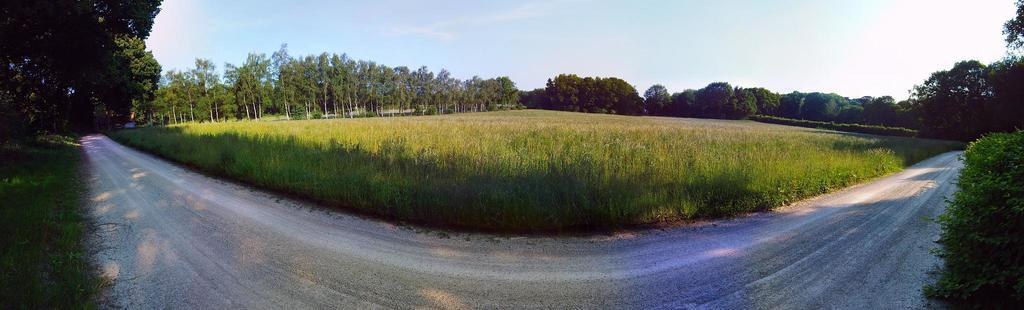What type of vegetation can be seen in the image? There are trees in the image. What type of surface is visible in the image? There is a road in the image. What type of ground cover is present in the image? There is grass in the image. What is visible in the background of the image? The sky is visible in the background of the image. What type of rhythm can be heard coming from the trees in the image? There is no sound or rhythm present in the image, as it is a still image of trees, a road, grass, and the sky. 